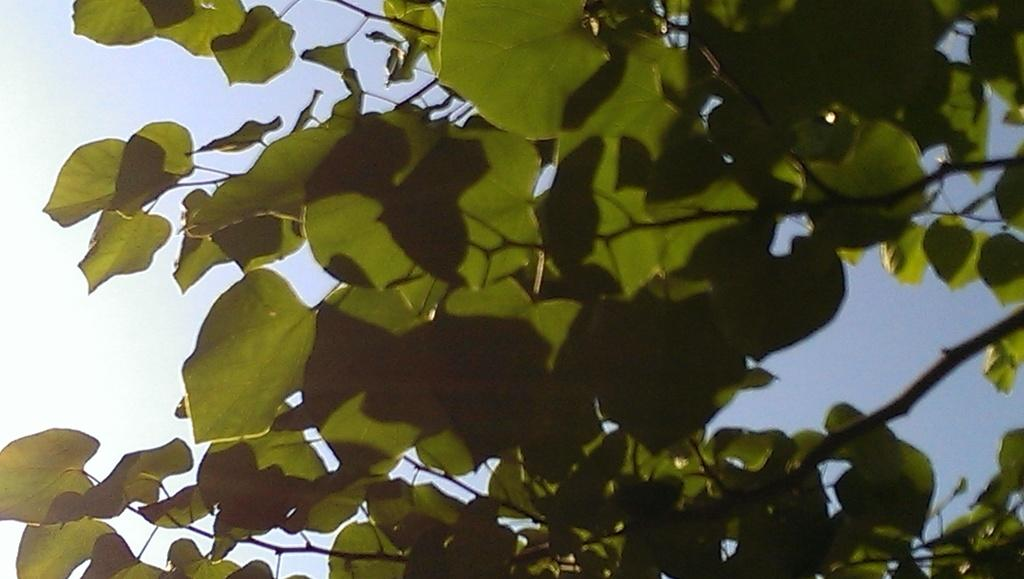What type of plant can be seen in the image? There is a tree in the image. What part of the natural environment is visible in the image? The sky is visible in the image. How much money does the tree in the image have? There is no indication of money in the image, as it features a tree and the sky. 